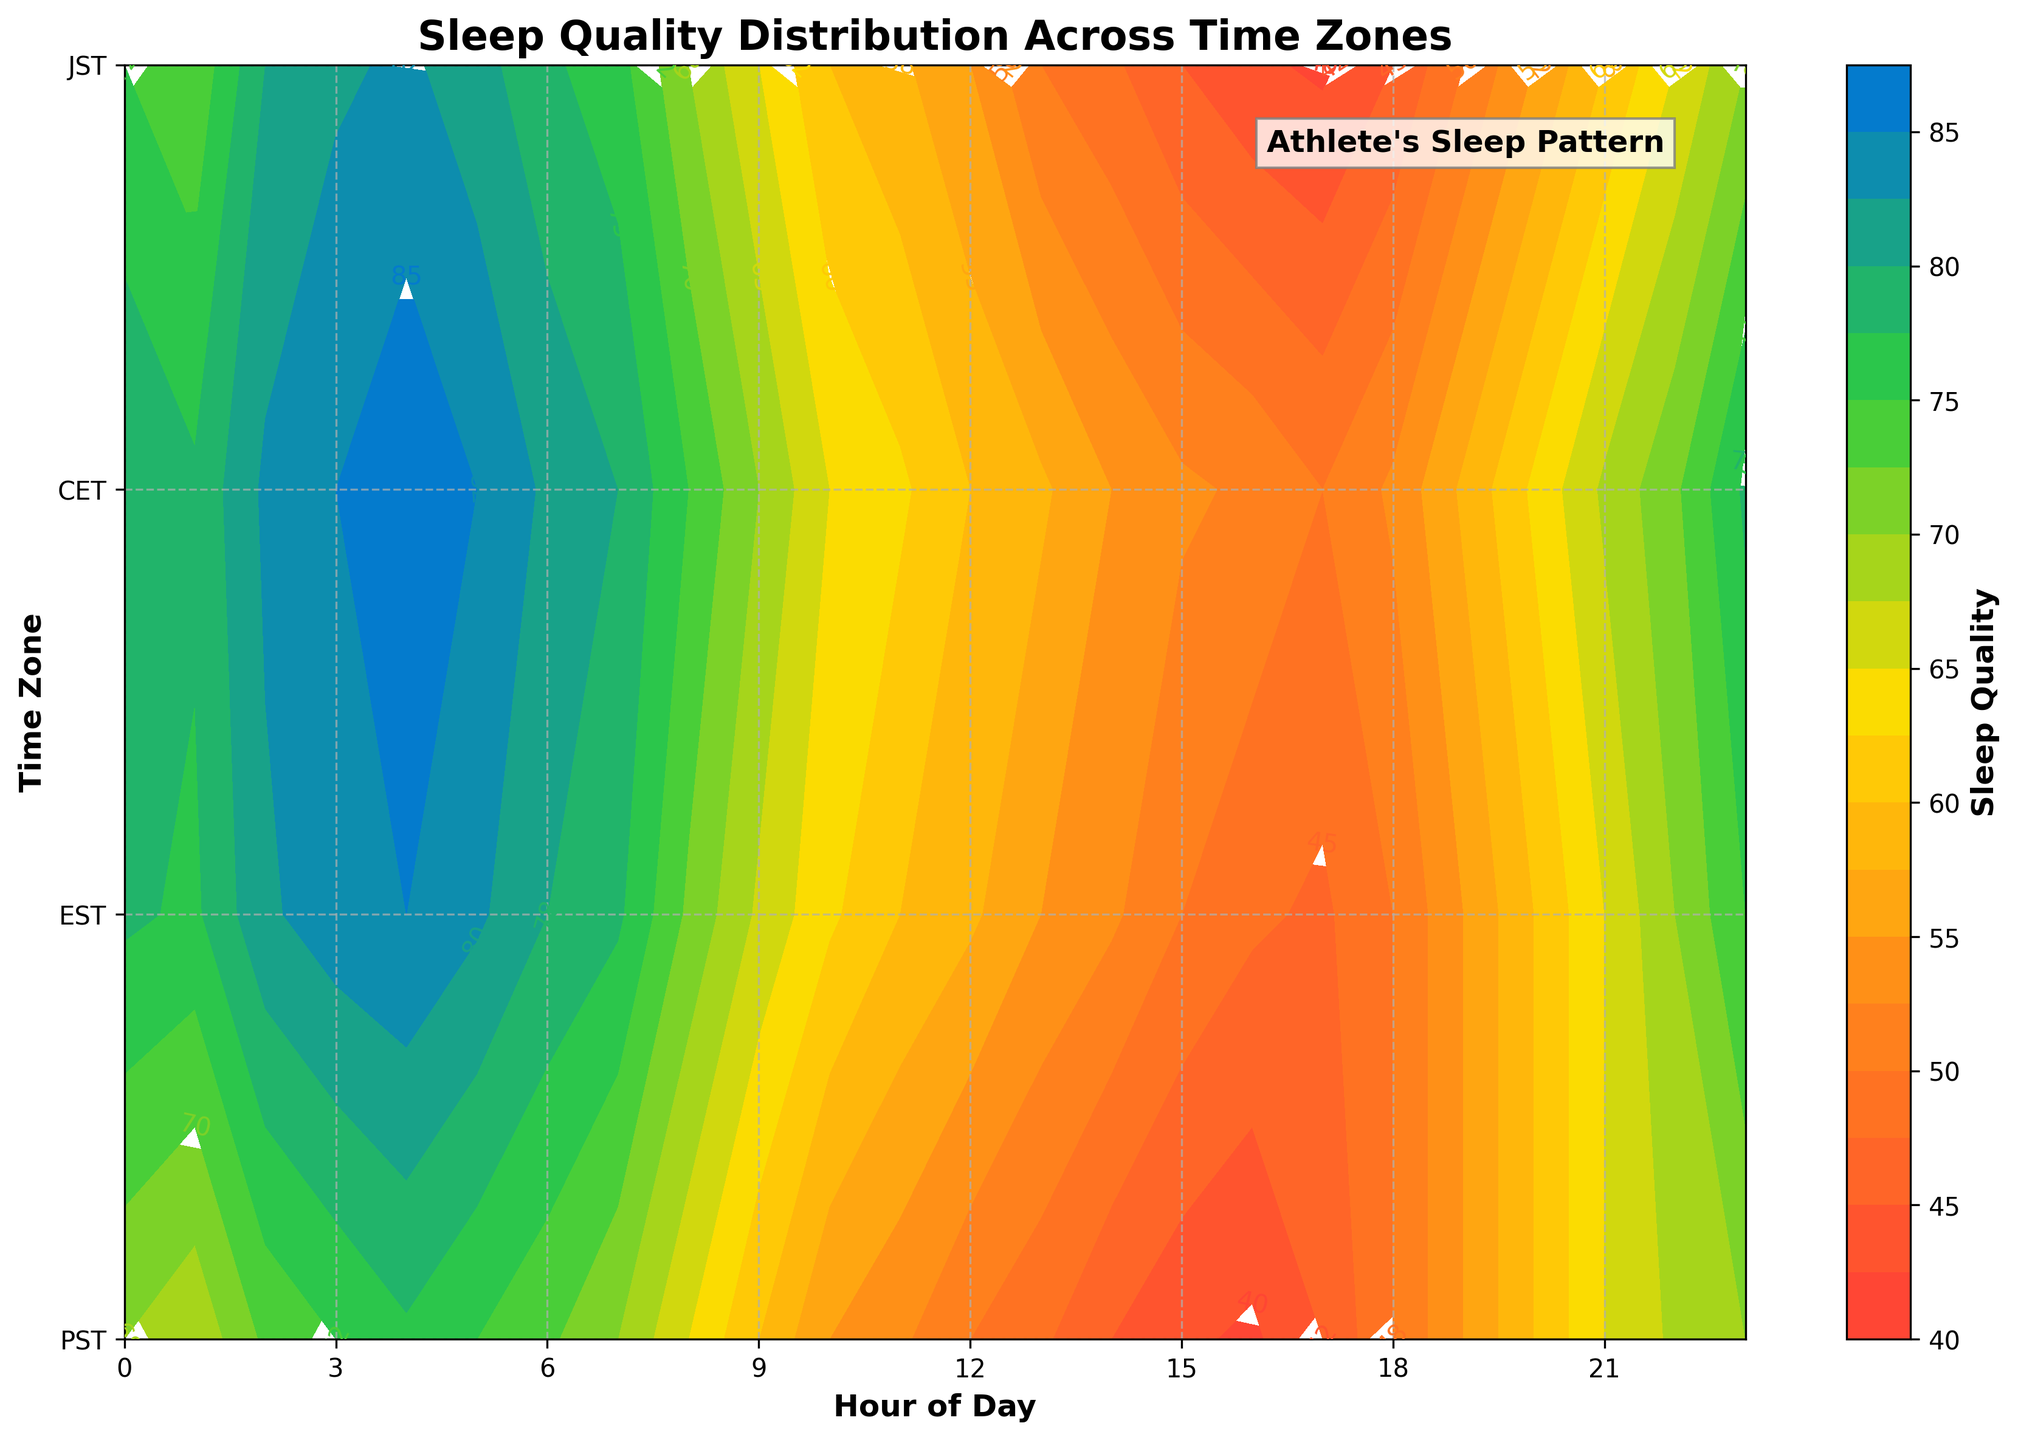What is the title of the figure? The title can be found at the top of the figure.
Answer: Sleep Quality Distribution Across Time Zones What is the x-axis labeled? The x-axis label is usually found below the x-axis line on the figure.
Answer: Hour of Day What is the highest sleep quality value in the PST time zone? Identify the contour line with the highest value in the PST row. The highest contour line is labeled 83 at 4 AM and 5 AM.
Answer: 83 Which time zone shows the peak sleep quality value earliest in the day? Review the peak sleep quality (highest value) appearance time across all time zones. For CET, the highest value is 77 at 4 AM. This is the earliest among time zones.
Answer: CET Between 12 PM and 1 PM, which time zone has the highest sleep quality? Review the contour values between 12 PM and 1 PM across all time zones. JST has the highest value of 63.
Answer: JST What range of sleep quality values is shown on the color bar? The color bar on the figure provides the range of sleep quality values. It ranges from the lowest to the highest value displayed.
Answer: 42 to 87 Is the sleep quality higher on average in the morning or the evening across all time zones? Summarize sleep quality values from 6 AM to 12 PM (morning) and from 6 PM to 12 AM (evening). Compare the averages. Morning values: higher.
Answer: Morning At what hour does sleep quality start to decline in the EST time zone? Identify the hour where a consistent decline in sleep quality begins. The decline starts after 4 AM, with 83 at 5 AM.
Answer: 5 AM Which time zone has the most consistent sleep quality throughout the day? Look at the contour lines across all hours, focusing on uniformity. CET shows less variation compared to others, suggesting more consistency.
Answer: CET How does the sleep quality pattern in JST compare with PST throughout the day? Compare the contour lines in JST and PST by observing the shapes and values throughout the 24 hours. JST has overall higher values and a smoother decline than PST, which fluctuates more.
Answer: JST has higher and more stable values compared to PST 